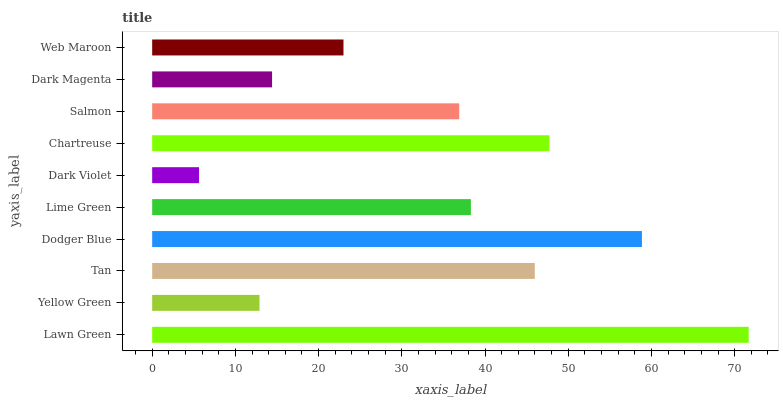Is Dark Violet the minimum?
Answer yes or no. Yes. Is Lawn Green the maximum?
Answer yes or no. Yes. Is Yellow Green the minimum?
Answer yes or no. No. Is Yellow Green the maximum?
Answer yes or no. No. Is Lawn Green greater than Yellow Green?
Answer yes or no. Yes. Is Yellow Green less than Lawn Green?
Answer yes or no. Yes. Is Yellow Green greater than Lawn Green?
Answer yes or no. No. Is Lawn Green less than Yellow Green?
Answer yes or no. No. Is Lime Green the high median?
Answer yes or no. Yes. Is Salmon the low median?
Answer yes or no. Yes. Is Chartreuse the high median?
Answer yes or no. No. Is Yellow Green the low median?
Answer yes or no. No. 